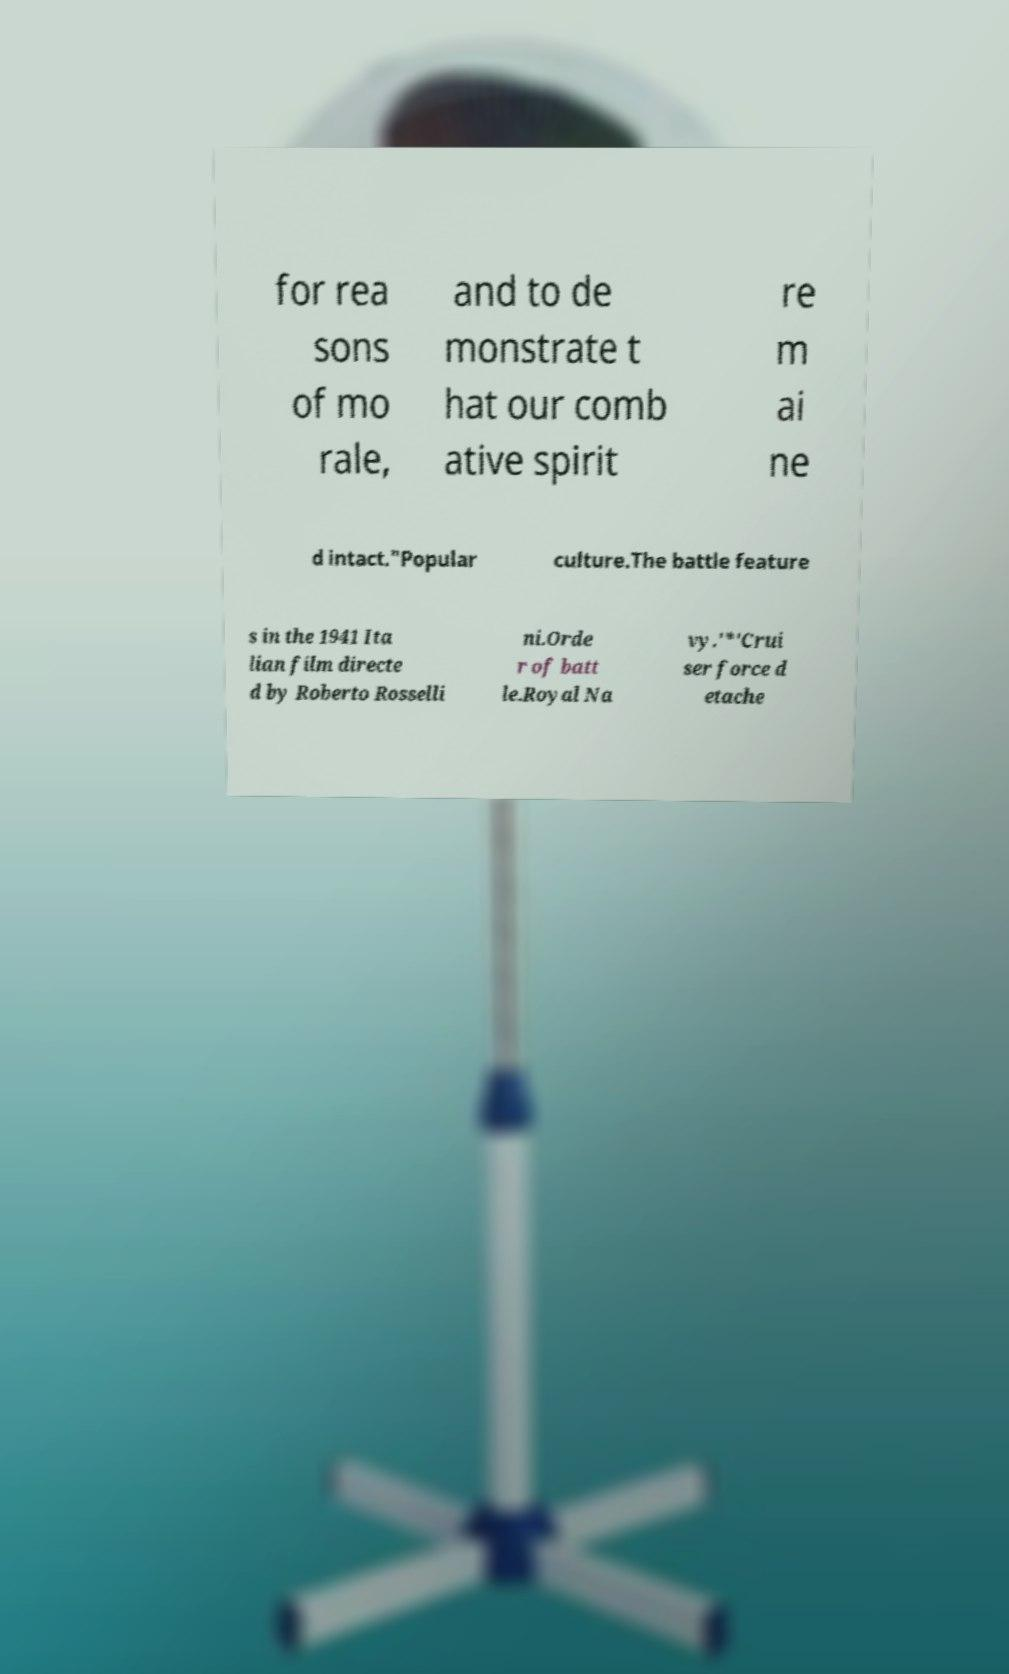Can you read and provide the text displayed in the image?This photo seems to have some interesting text. Can you extract and type it out for me? for rea sons of mo rale, and to de monstrate t hat our comb ative spirit re m ai ne d intact."Popular culture.The battle feature s in the 1941 Ita lian film directe d by Roberto Rosselli ni.Orde r of batt le.Royal Na vy.'*'Crui ser force d etache 